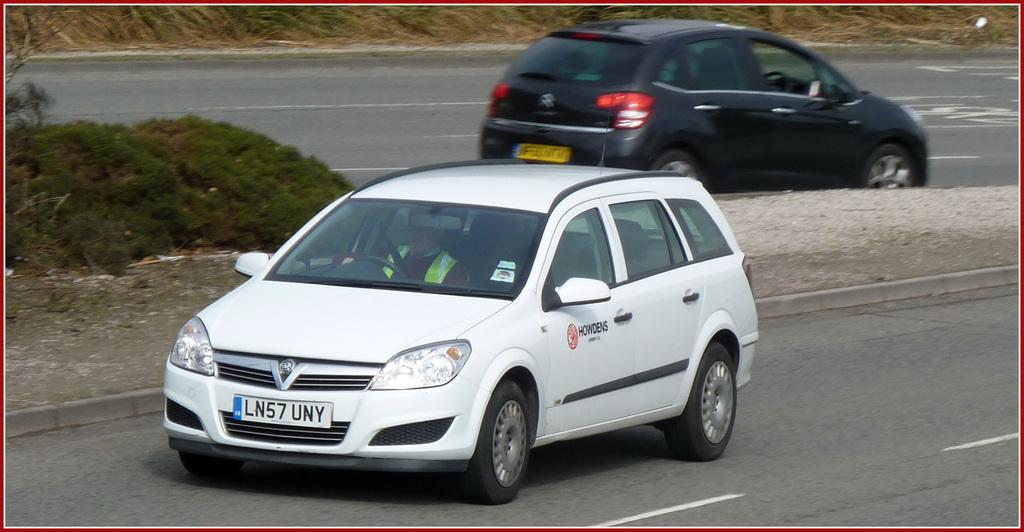<image>
Provide a brief description of the given image. A white vehicle has the license plate number LN57 UNY. 